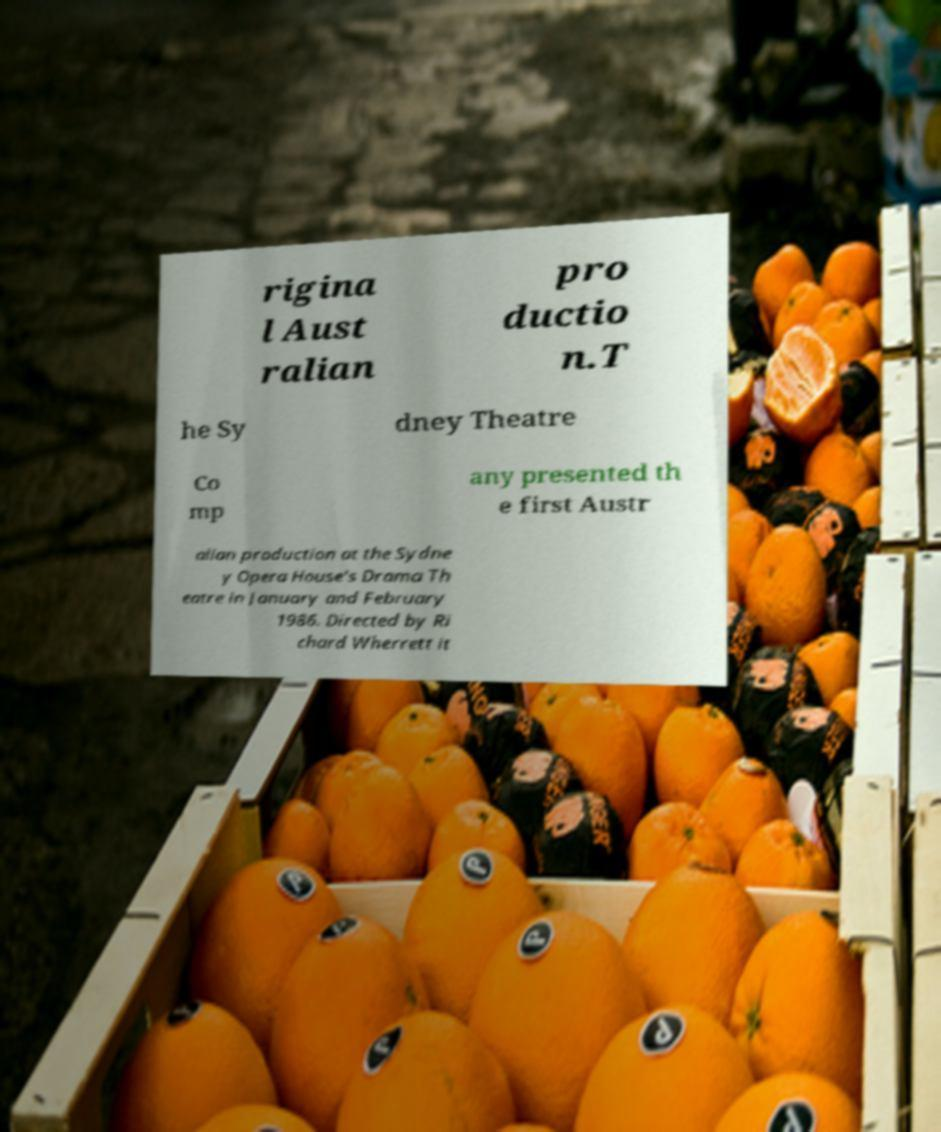I need the written content from this picture converted into text. Can you do that? rigina l Aust ralian pro ductio n.T he Sy dney Theatre Co mp any presented th e first Austr alian production at the Sydne y Opera House's Drama Th eatre in January and February 1986. Directed by Ri chard Wherrett it 